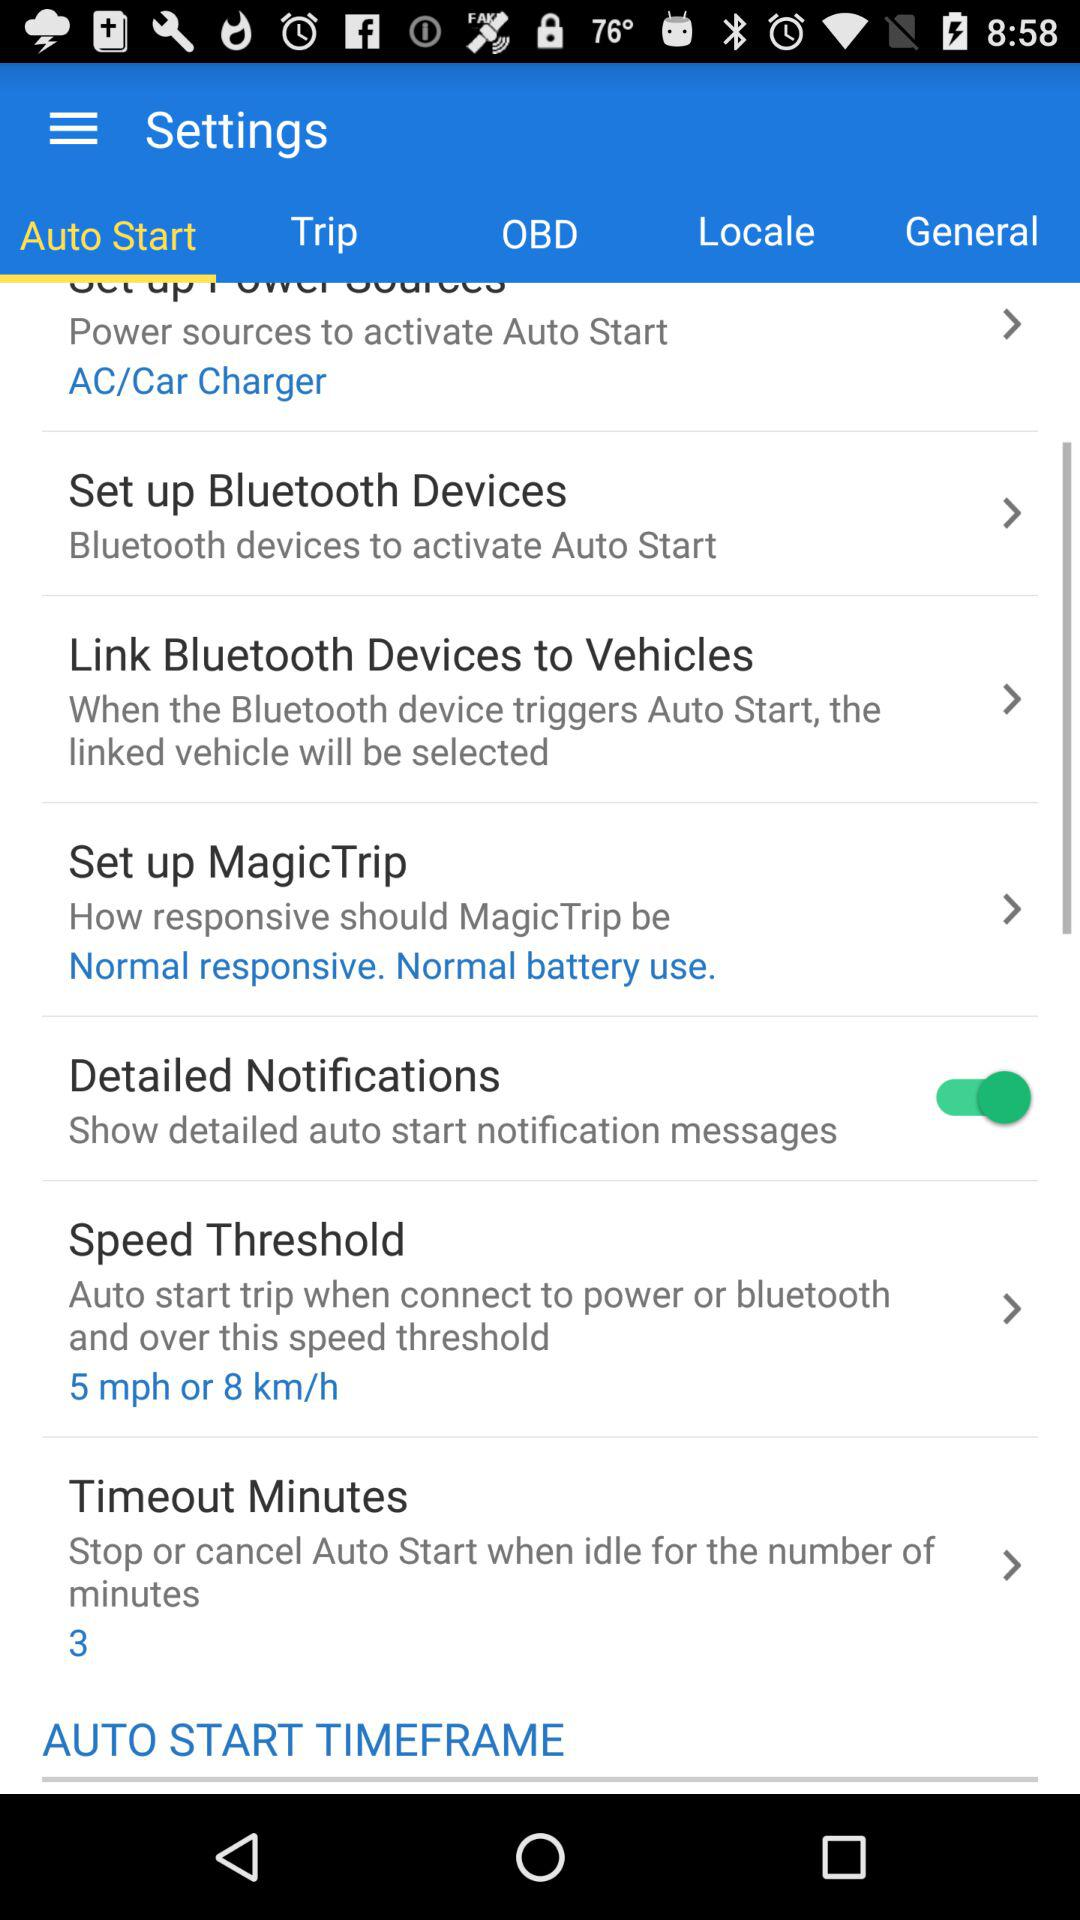What is the description given in the "Set up Bluetooth Devices"? The description is "Bluetooth devices to activate Auto Start". 